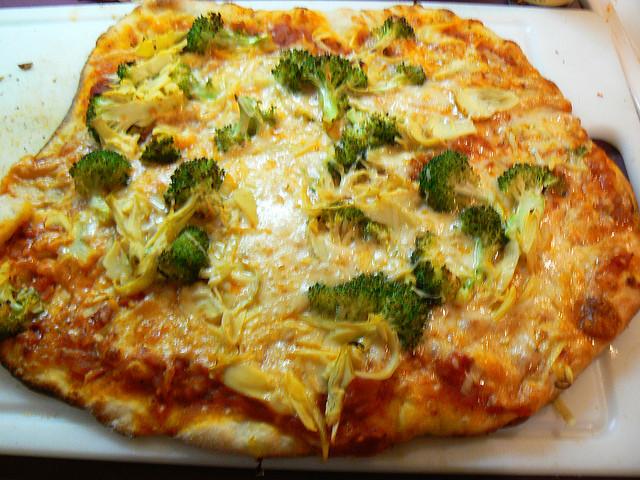Is the cheese melted?
Concise answer only. Yes. Is this a hamburger?
Keep it brief. No. What's on the pizza?
Concise answer only. Broccoli. Does this pizza have meat on it?
Short answer required. No. What vegetable is on the pizza?
Give a very brief answer. Broccoli. What is the topping?
Give a very brief answer. Broccoli. What shape is the pizza?
Write a very short answer. Circle. What is the green stuff on the pizza?
Answer briefly. Broccoli. Are there bacon pieces included in the food?
Keep it brief. No. Is this one dish cut into two pieces?
Answer briefly. No. What kind of pizza is shown?
Keep it brief. Broccoli. What vegetable is on top of the pizza?
Short answer required. Broccoli. 